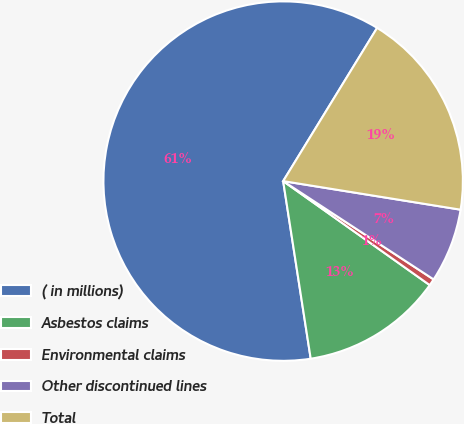<chart> <loc_0><loc_0><loc_500><loc_500><pie_chart><fcel>( in millions)<fcel>Asbestos claims<fcel>Environmental claims<fcel>Other discontinued lines<fcel>Total<nl><fcel>61.21%<fcel>12.73%<fcel>0.61%<fcel>6.67%<fcel>18.79%<nl></chart> 